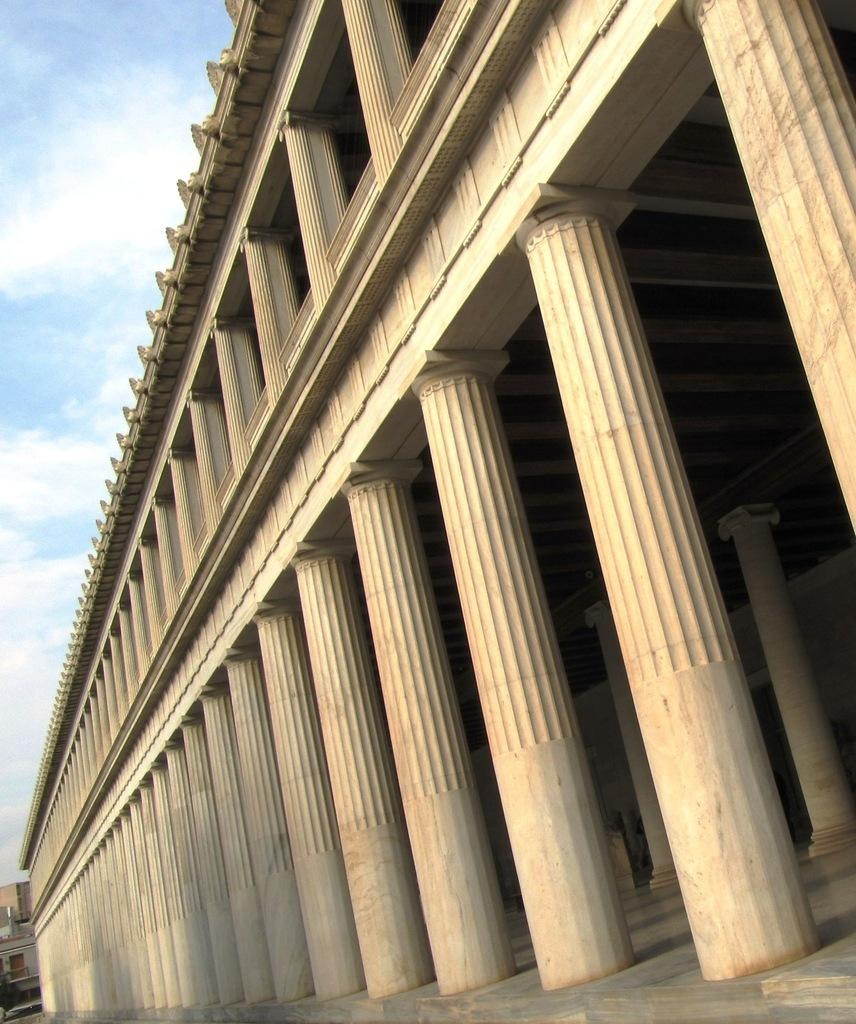What type of structure is present in the image? There is a building in the image. What architectural feature can be seen on the building? The building has many pillars. What is visible at the top of the image? The sky is visible at the top of the image. How many cars are parked in front of the building in the image? There are no cars present in the image; it only shows a building with many pillars and the sky visible at the top. 